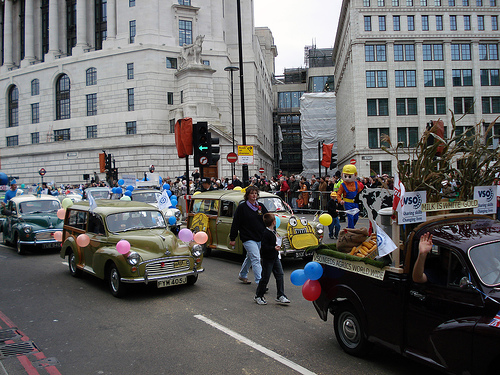<image>
Can you confirm if the car is behind the car? Yes. From this viewpoint, the car is positioned behind the car, with the car partially or fully occluding the car. 